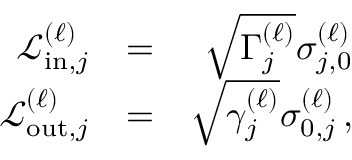Convert formula to latex. <formula><loc_0><loc_0><loc_500><loc_500>\begin{array} { r l r } { \mathcal { L } _ { i n , j } ^ { ( \ell ) } } & { = } & { \sqrt { \Gamma _ { j } ^ { ( \ell ) } } \sigma _ { j , 0 } ^ { \left ( \ell \right ) } } \\ { \mathcal { L } _ { o u t , j } ^ { ( \ell ) } } & { = } & { \sqrt { \gamma _ { j } ^ { ( \ell ) } } \sigma _ { 0 , j } ^ { \left ( \ell \right ) } \, , } \end{array}</formula> 